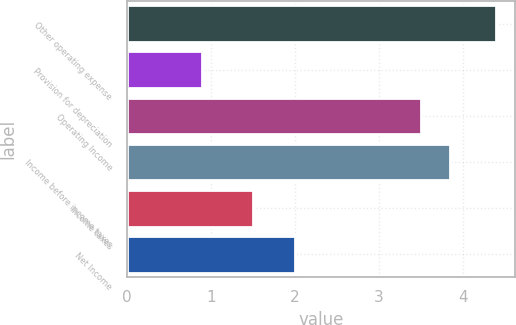Convert chart to OTSL. <chart><loc_0><loc_0><loc_500><loc_500><bar_chart><fcel>Other operating expense<fcel>Provision for depreciation<fcel>Operating Income<fcel>Income before income taxes<fcel>Income taxes<fcel>Net Income<nl><fcel>4.4<fcel>0.9<fcel>3.5<fcel>3.85<fcel>1.5<fcel>2<nl></chart> 